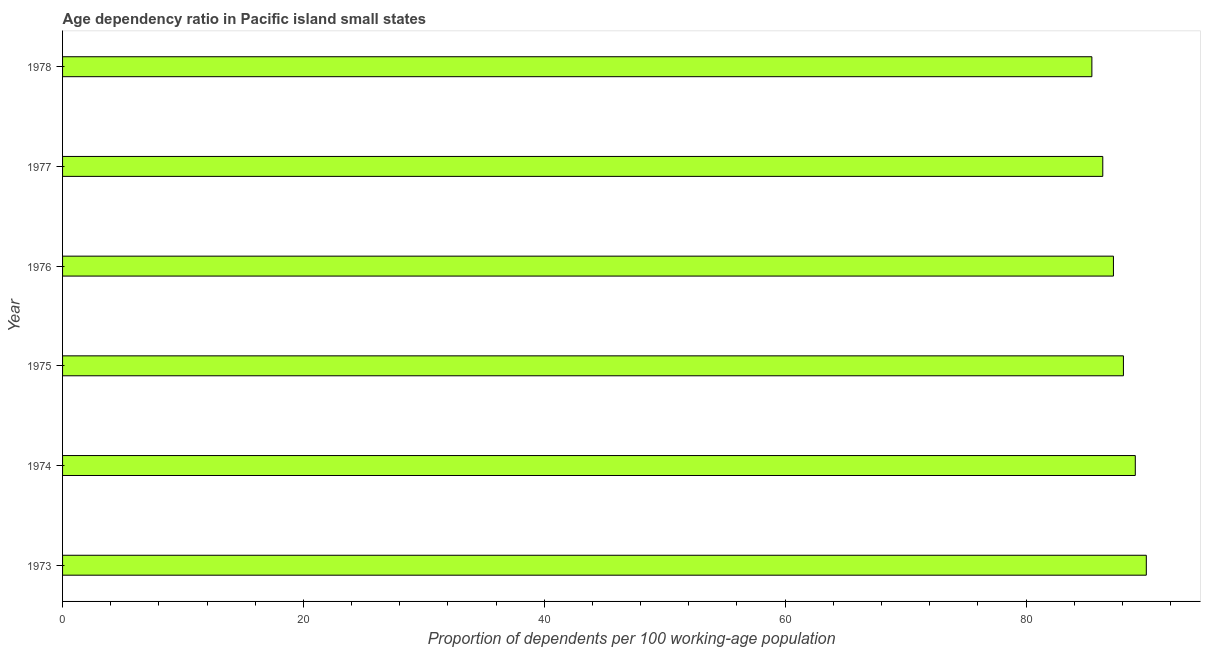Does the graph contain any zero values?
Keep it short and to the point. No. Does the graph contain grids?
Make the answer very short. No. What is the title of the graph?
Ensure brevity in your answer.  Age dependency ratio in Pacific island small states. What is the label or title of the X-axis?
Your response must be concise. Proportion of dependents per 100 working-age population. What is the age dependency ratio in 1975?
Provide a short and direct response. 88.09. Across all years, what is the maximum age dependency ratio?
Offer a terse response. 89.99. Across all years, what is the minimum age dependency ratio?
Ensure brevity in your answer.  85.47. In which year was the age dependency ratio minimum?
Ensure brevity in your answer.  1978. What is the sum of the age dependency ratio?
Make the answer very short. 526.26. What is the average age dependency ratio per year?
Your answer should be very brief. 87.71. What is the median age dependency ratio?
Your answer should be very brief. 87.68. In how many years, is the age dependency ratio greater than 48 ?
Make the answer very short. 6. Is the age dependency ratio in 1976 less than that in 1977?
Offer a very short reply. No. What is the difference between the highest and the second highest age dependency ratio?
Give a very brief answer. 0.91. What is the difference between the highest and the lowest age dependency ratio?
Ensure brevity in your answer.  4.52. In how many years, is the age dependency ratio greater than the average age dependency ratio taken over all years?
Provide a succinct answer. 3. How many bars are there?
Offer a terse response. 6. Are all the bars in the graph horizontal?
Ensure brevity in your answer.  Yes. How many years are there in the graph?
Keep it short and to the point. 6. What is the difference between two consecutive major ticks on the X-axis?
Keep it short and to the point. 20. Are the values on the major ticks of X-axis written in scientific E-notation?
Make the answer very short. No. What is the Proportion of dependents per 100 working-age population in 1973?
Your response must be concise. 89.99. What is the Proportion of dependents per 100 working-age population in 1974?
Ensure brevity in your answer.  89.08. What is the Proportion of dependents per 100 working-age population of 1975?
Ensure brevity in your answer.  88.09. What is the Proportion of dependents per 100 working-age population in 1976?
Provide a short and direct response. 87.26. What is the Proportion of dependents per 100 working-age population in 1977?
Your response must be concise. 86.38. What is the Proportion of dependents per 100 working-age population in 1978?
Your answer should be very brief. 85.47. What is the difference between the Proportion of dependents per 100 working-age population in 1973 and 1974?
Your answer should be very brief. 0.91. What is the difference between the Proportion of dependents per 100 working-age population in 1973 and 1975?
Offer a terse response. 1.9. What is the difference between the Proportion of dependents per 100 working-age population in 1973 and 1976?
Your answer should be compact. 2.73. What is the difference between the Proportion of dependents per 100 working-age population in 1973 and 1977?
Ensure brevity in your answer.  3.61. What is the difference between the Proportion of dependents per 100 working-age population in 1973 and 1978?
Give a very brief answer. 4.52. What is the difference between the Proportion of dependents per 100 working-age population in 1974 and 1975?
Your answer should be very brief. 0.99. What is the difference between the Proportion of dependents per 100 working-age population in 1974 and 1976?
Ensure brevity in your answer.  1.82. What is the difference between the Proportion of dependents per 100 working-age population in 1974 and 1977?
Your answer should be compact. 2.7. What is the difference between the Proportion of dependents per 100 working-age population in 1974 and 1978?
Provide a short and direct response. 3.6. What is the difference between the Proportion of dependents per 100 working-age population in 1975 and 1976?
Your answer should be very brief. 0.83. What is the difference between the Proportion of dependents per 100 working-age population in 1975 and 1977?
Provide a short and direct response. 1.71. What is the difference between the Proportion of dependents per 100 working-age population in 1975 and 1978?
Your answer should be compact. 2.62. What is the difference between the Proportion of dependents per 100 working-age population in 1976 and 1977?
Give a very brief answer. 0.88. What is the difference between the Proportion of dependents per 100 working-age population in 1976 and 1978?
Offer a very short reply. 1.79. What is the difference between the Proportion of dependents per 100 working-age population in 1977 and 1978?
Provide a succinct answer. 0.9. What is the ratio of the Proportion of dependents per 100 working-age population in 1973 to that in 1976?
Your answer should be compact. 1.03. What is the ratio of the Proportion of dependents per 100 working-age population in 1973 to that in 1977?
Provide a short and direct response. 1.04. What is the ratio of the Proportion of dependents per 100 working-age population in 1973 to that in 1978?
Provide a succinct answer. 1.05. What is the ratio of the Proportion of dependents per 100 working-age population in 1974 to that in 1976?
Make the answer very short. 1.02. What is the ratio of the Proportion of dependents per 100 working-age population in 1974 to that in 1977?
Provide a succinct answer. 1.03. What is the ratio of the Proportion of dependents per 100 working-age population in 1974 to that in 1978?
Offer a very short reply. 1.04. What is the ratio of the Proportion of dependents per 100 working-age population in 1975 to that in 1978?
Your answer should be compact. 1.03. What is the ratio of the Proportion of dependents per 100 working-age population in 1976 to that in 1978?
Keep it short and to the point. 1.02. What is the ratio of the Proportion of dependents per 100 working-age population in 1977 to that in 1978?
Your response must be concise. 1.01. 